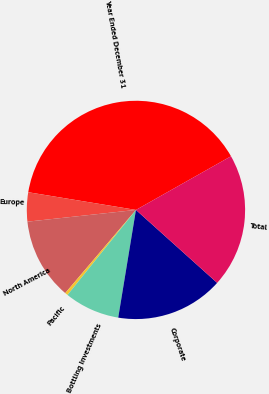<chart> <loc_0><loc_0><loc_500><loc_500><pie_chart><fcel>Year Ended December 31<fcel>Europe<fcel>North America<fcel>Pacific<fcel>Bottling Investments<fcel>Corporate<fcel>Total<nl><fcel>39.23%<fcel>4.31%<fcel>12.07%<fcel>0.43%<fcel>8.19%<fcel>15.95%<fcel>19.83%<nl></chart> 